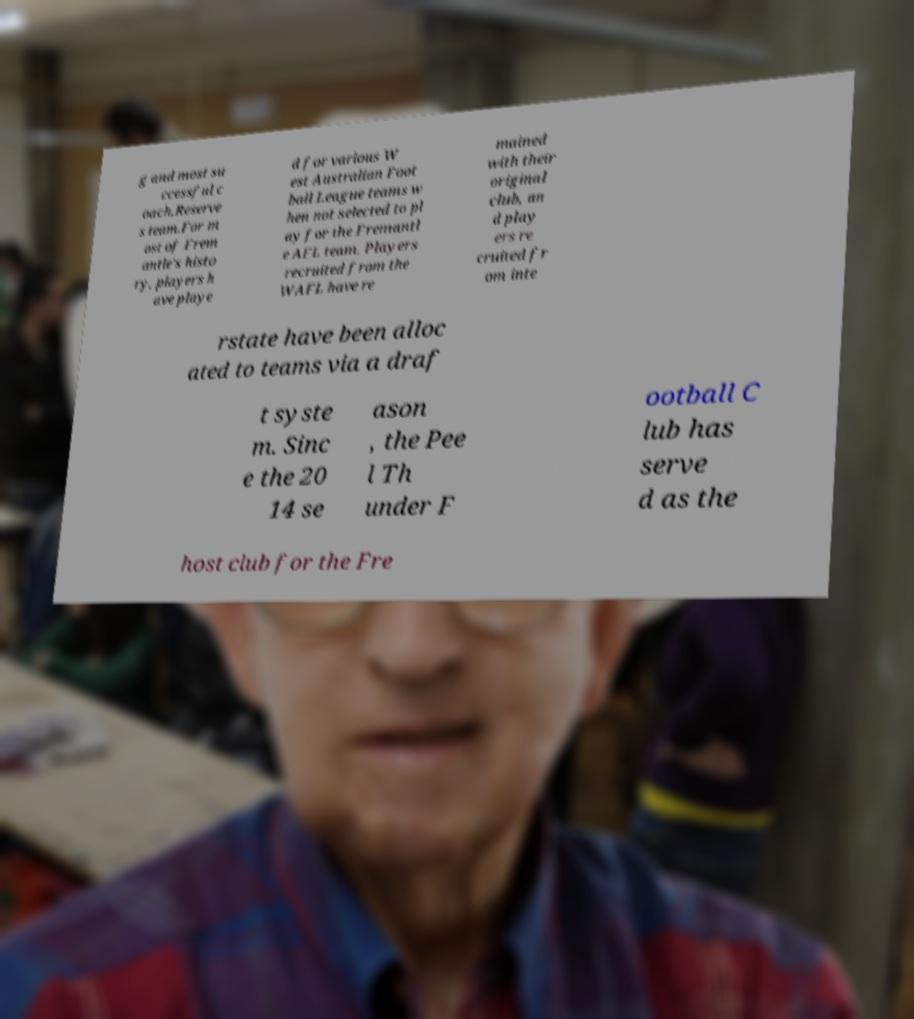I need the written content from this picture converted into text. Can you do that? g and most su ccessful c oach.Reserve s team.For m ost of Frem antle's histo ry, players h ave playe d for various W est Australian Foot ball League teams w hen not selected to pl ay for the Fremantl e AFL team. Players recruited from the WAFL have re mained with their original club, an d play ers re cruited fr om inte rstate have been alloc ated to teams via a draf t syste m. Sinc e the 20 14 se ason , the Pee l Th under F ootball C lub has serve d as the host club for the Fre 